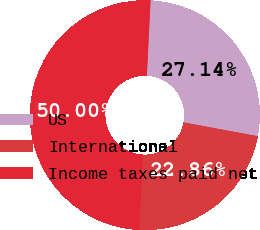<chart> <loc_0><loc_0><loc_500><loc_500><pie_chart><fcel>US<fcel>International<fcel>Income taxes paid net<nl><fcel>27.14%<fcel>22.86%<fcel>50.0%<nl></chart> 